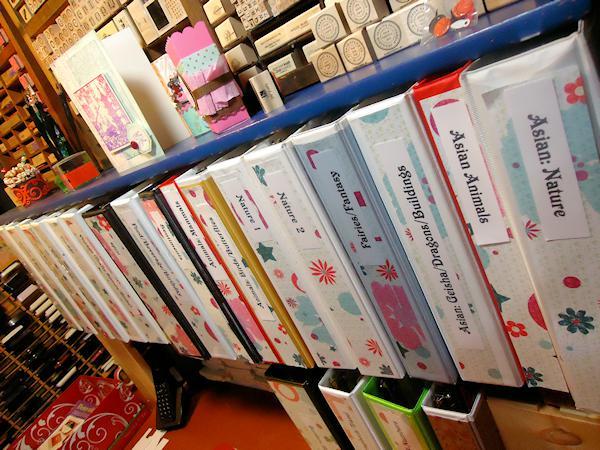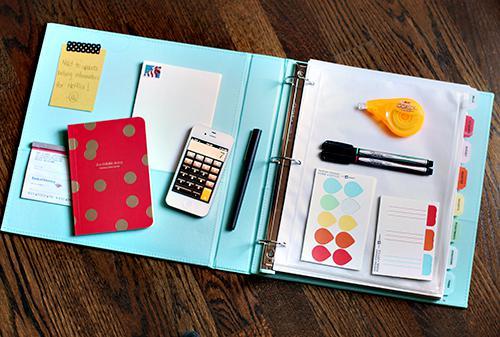The first image is the image on the left, the second image is the image on the right. Assess this claim about the two images: "At least one binder with pages in it is opened.". Correct or not? Answer yes or no. Yes. The first image is the image on the left, the second image is the image on the right. Analyze the images presented: Is the assertion "There is an open binder." valid? Answer yes or no. Yes. 